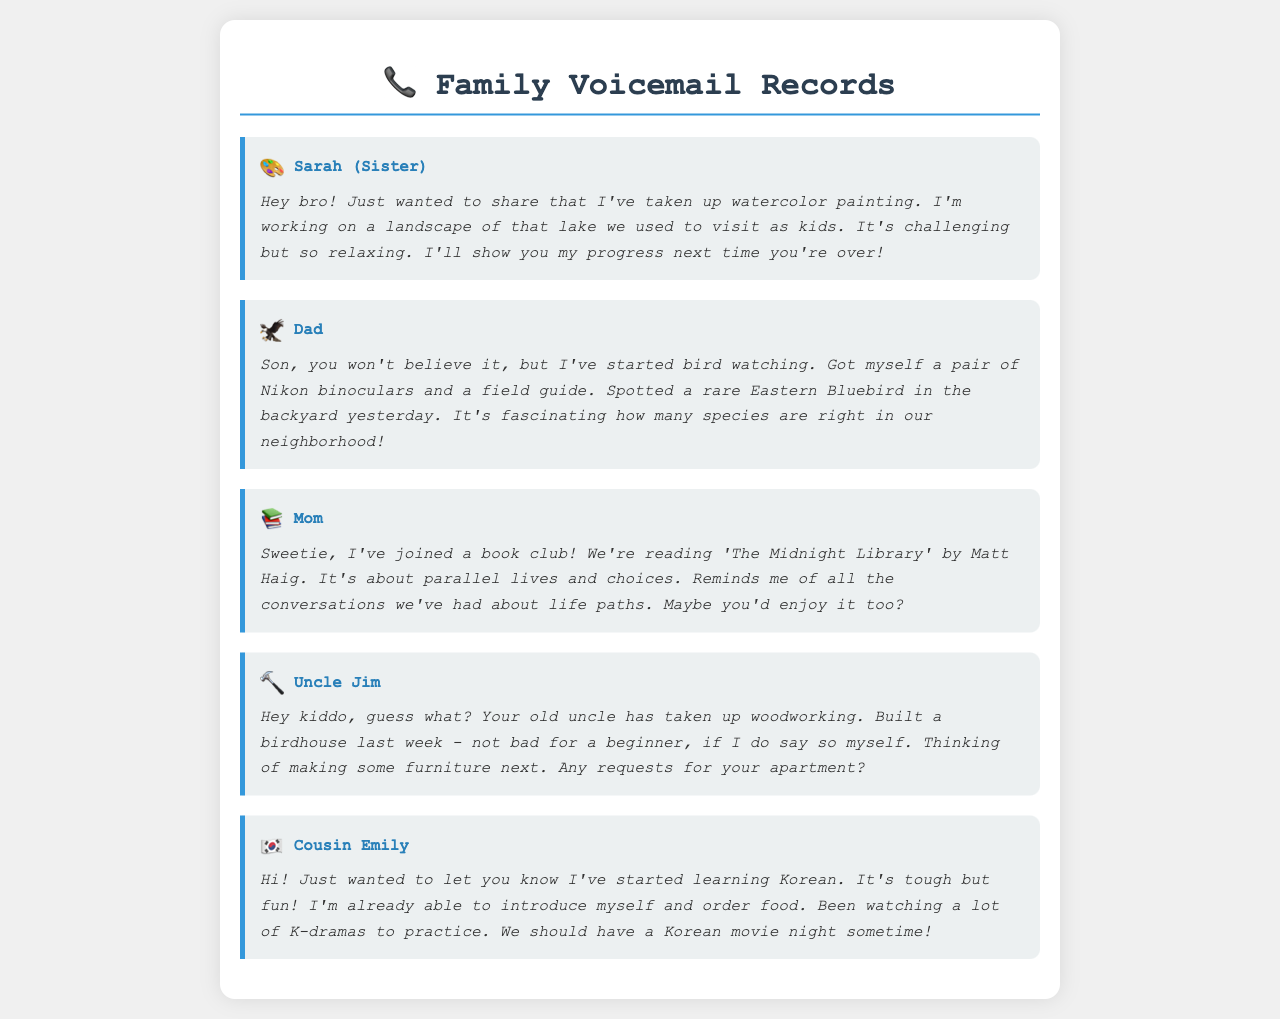What hobby has Sarah taken up? Sarah has taken up watercolor painting as mentioned in her voicemail.
Answer: Watercolor painting What is Dad's new interest? Dad has started bird watching and mentioned spotting a rare Eastern Bluebird.
Answer: Bird watching What book is Mom's book club reading? Mom's book club is reading 'The Midnight Library' by Matt Haig.
Answer: The Midnight Library What did Uncle Jim build last week? Uncle Jim built a birdhouse last week as stated in his voicemail.
Answer: A birdhouse What language is Cousin Emily learning? Cousin Emily is learning Korean, as mentioned in her voicemail.
Answer: Korean Why does Mom think you might enjoy the book? Mom thinks you might enjoy the book because it reminds her of all the conversations you've had about life paths.
Answer: Life paths How did Sarah describe painting? Sarah described painting as challenging but relaxing.
Answer: Challenging but relaxing What does Uncle Jim offer to make for your apartment? Uncle Jim offers to make furniture for your apartment.
Answer: Furniture 